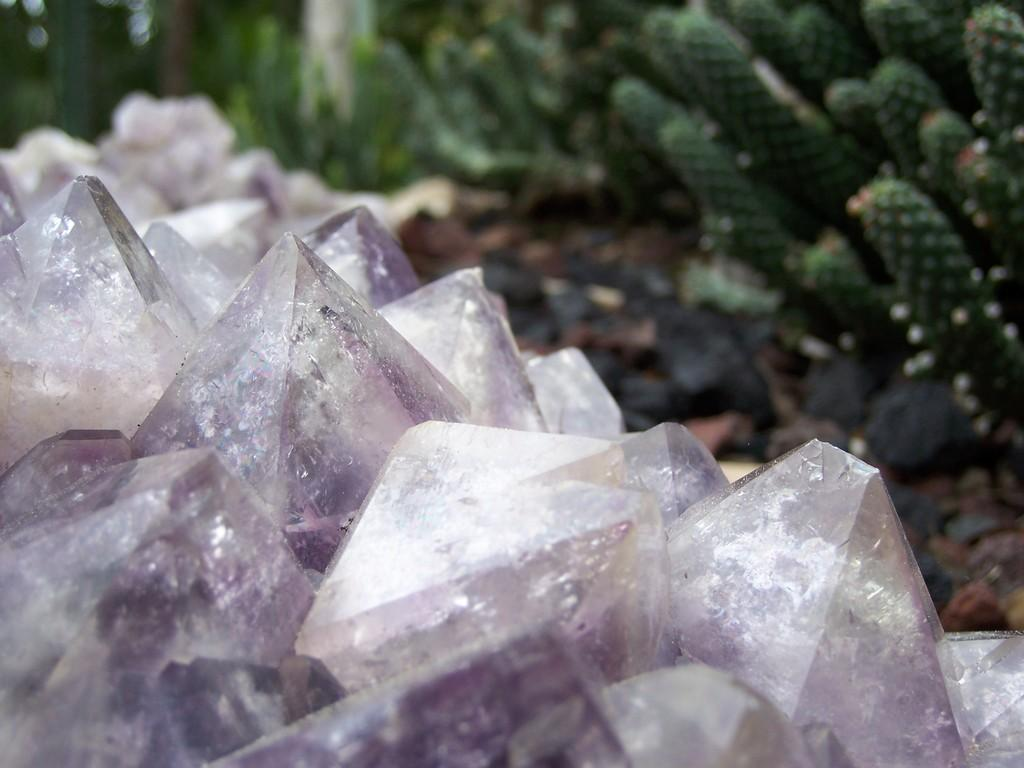What objects can be seen in the image? There are crystals and green colored plants in the image. Can you describe the appearance of the plants? The plants are green in color. What is the condition of the background in the image? The background of the image is blurred. What type of cream can be seen on the crystals in the image? There is no cream present on the crystals in the image. How does the kitty interact with the crystals in the image? There is no kitty present in the image, so it cannot interact with the crystals. 